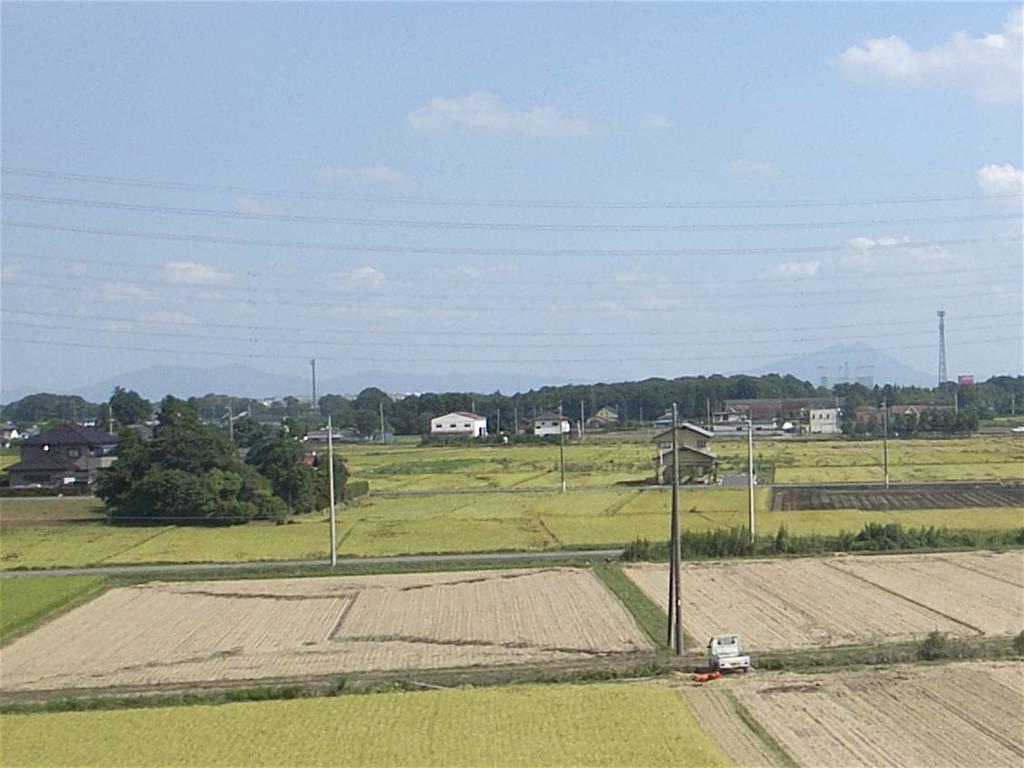In one or two sentences, can you explain what this image depicts? In this image I can see a form in the form I can see a poles, houses, trees, a road,vehicle,at the top I can see the sky, power line cables, in the middle I can see buildings, trees 